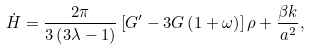Convert formula to latex. <formula><loc_0><loc_0><loc_500><loc_500>\dot { H } = \frac { 2 \pi } { 3 \left ( 3 \lambda - 1 \right ) } \left [ G ^ { \prime } - 3 G \left ( 1 + \omega \right ) \right ] \rho + \frac { \beta k } { a ^ { 2 } } ,</formula> 